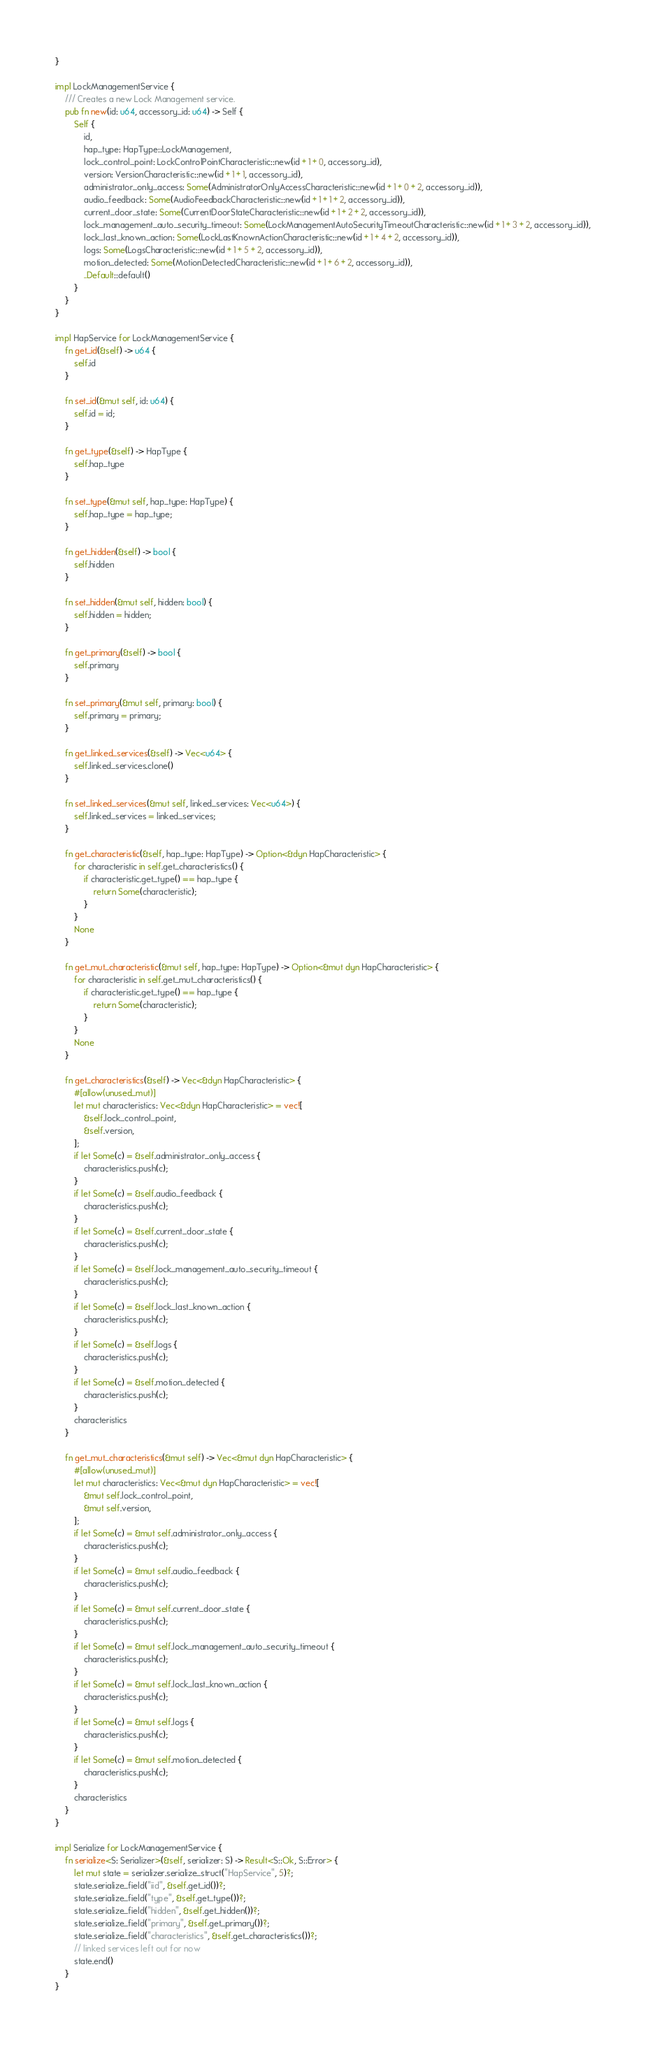<code> <loc_0><loc_0><loc_500><loc_500><_Rust_>}

impl LockManagementService {
    /// Creates a new Lock Management service.
    pub fn new(id: u64, accessory_id: u64) -> Self {
        Self {
            id,
            hap_type: HapType::LockManagement,
			lock_control_point: LockControlPointCharacteristic::new(id + 1 + 0, accessory_id),
			version: VersionCharacteristic::new(id + 1 + 1, accessory_id),
			administrator_only_access: Some(AdministratorOnlyAccessCharacteristic::new(id + 1 + 0 + 2, accessory_id)),
			audio_feedback: Some(AudioFeedbackCharacteristic::new(id + 1 + 1 + 2, accessory_id)),
			current_door_state: Some(CurrentDoorStateCharacteristic::new(id + 1 + 2 + 2, accessory_id)),
			lock_management_auto_security_timeout: Some(LockManagementAutoSecurityTimeoutCharacteristic::new(id + 1 + 3 + 2, accessory_id)),
			lock_last_known_action: Some(LockLastKnownActionCharacteristic::new(id + 1 + 4 + 2, accessory_id)),
			logs: Some(LogsCharacteristic::new(id + 1 + 5 + 2, accessory_id)),
			motion_detected: Some(MotionDetectedCharacteristic::new(id + 1 + 6 + 2, accessory_id)),
			..Default::default()
        }
    }
}

impl HapService for LockManagementService {
    fn get_id(&self) -> u64 {
        self.id
    }

    fn set_id(&mut self, id: u64) {
        self.id = id;
    }

    fn get_type(&self) -> HapType {
        self.hap_type
    }

    fn set_type(&mut self, hap_type: HapType) {
        self.hap_type = hap_type;
    }

    fn get_hidden(&self) -> bool {
        self.hidden
    }

    fn set_hidden(&mut self, hidden: bool) {
        self.hidden = hidden;
    }

    fn get_primary(&self) -> bool {
        self.primary
    }

    fn set_primary(&mut self, primary: bool) {
        self.primary = primary;
    }

    fn get_linked_services(&self) -> Vec<u64> {
        self.linked_services.clone()
    }

    fn set_linked_services(&mut self, linked_services: Vec<u64>) {
        self.linked_services = linked_services;
    }

    fn get_characteristic(&self, hap_type: HapType) -> Option<&dyn HapCharacteristic> {
        for characteristic in self.get_characteristics() {
            if characteristic.get_type() == hap_type {
                return Some(characteristic);
            }
        }
        None
    }

    fn get_mut_characteristic(&mut self, hap_type: HapType) -> Option<&mut dyn HapCharacteristic> {
        for characteristic in self.get_mut_characteristics() {
            if characteristic.get_type() == hap_type {
                return Some(characteristic);
            }
        }
        None
    }

    fn get_characteristics(&self) -> Vec<&dyn HapCharacteristic> {
        #[allow(unused_mut)]
        let mut characteristics: Vec<&dyn HapCharacteristic> = vec![
			&self.lock_control_point,
			&self.version,
		];
		if let Some(c) = &self.administrator_only_access {
		    characteristics.push(c);
		}
		if let Some(c) = &self.audio_feedback {
		    characteristics.push(c);
		}
		if let Some(c) = &self.current_door_state {
		    characteristics.push(c);
		}
		if let Some(c) = &self.lock_management_auto_security_timeout {
		    characteristics.push(c);
		}
		if let Some(c) = &self.lock_last_known_action {
		    characteristics.push(c);
		}
		if let Some(c) = &self.logs {
		    characteristics.push(c);
		}
		if let Some(c) = &self.motion_detected {
		    characteristics.push(c);
		}
		characteristics
    }

    fn get_mut_characteristics(&mut self) -> Vec<&mut dyn HapCharacteristic> {
        #[allow(unused_mut)]
        let mut characteristics: Vec<&mut dyn HapCharacteristic> = vec![
			&mut self.lock_control_point,
			&mut self.version,
		];
		if let Some(c) = &mut self.administrator_only_access {
		    characteristics.push(c);
		}
		if let Some(c) = &mut self.audio_feedback {
		    characteristics.push(c);
		}
		if let Some(c) = &mut self.current_door_state {
		    characteristics.push(c);
		}
		if let Some(c) = &mut self.lock_management_auto_security_timeout {
		    characteristics.push(c);
		}
		if let Some(c) = &mut self.lock_last_known_action {
		    characteristics.push(c);
		}
		if let Some(c) = &mut self.logs {
		    characteristics.push(c);
		}
		if let Some(c) = &mut self.motion_detected {
		    characteristics.push(c);
		}
		characteristics
    }
}

impl Serialize for LockManagementService {
    fn serialize<S: Serializer>(&self, serializer: S) -> Result<S::Ok, S::Error> {
        let mut state = serializer.serialize_struct("HapService", 5)?;
        state.serialize_field("iid", &self.get_id())?;
        state.serialize_field("type", &self.get_type())?;
        state.serialize_field("hidden", &self.get_hidden())?;
        state.serialize_field("primary", &self.get_primary())?;
        state.serialize_field("characteristics", &self.get_characteristics())?;
        // linked services left out for now
        state.end()
    }
}
</code> 